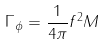<formula> <loc_0><loc_0><loc_500><loc_500>\Gamma _ { \phi } = \frac { 1 } { 4 \pi } f ^ { 2 } M</formula> 